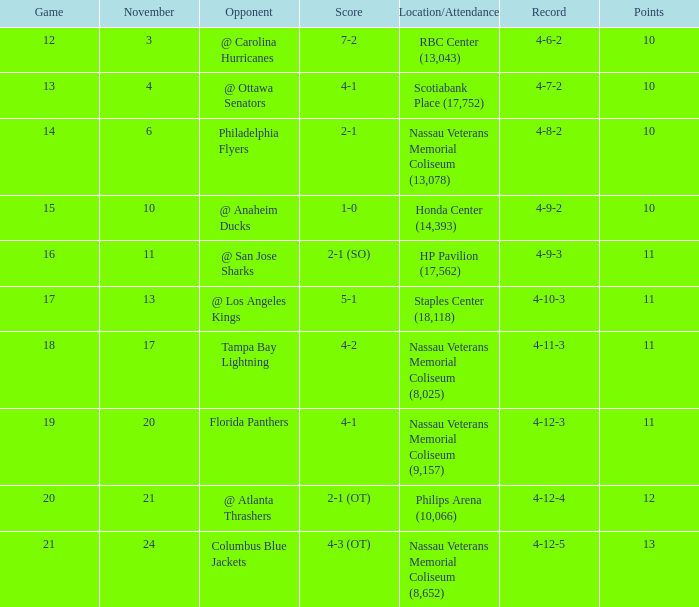What is every game on November 21? 20.0. 